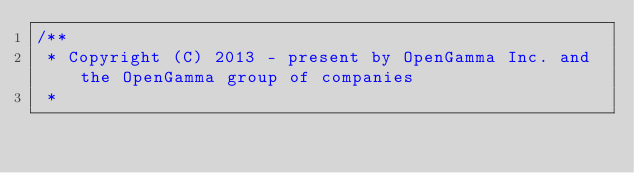Convert code to text. <code><loc_0><loc_0><loc_500><loc_500><_Java_>/**
 * Copyright (C) 2013 - present by OpenGamma Inc. and the OpenGamma group of companies
 *</code> 